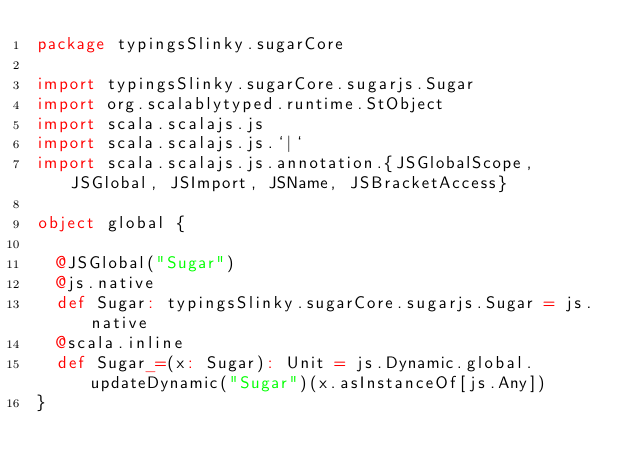<code> <loc_0><loc_0><loc_500><loc_500><_Scala_>package typingsSlinky.sugarCore

import typingsSlinky.sugarCore.sugarjs.Sugar
import org.scalablytyped.runtime.StObject
import scala.scalajs.js
import scala.scalajs.js.`|`
import scala.scalajs.js.annotation.{JSGlobalScope, JSGlobal, JSImport, JSName, JSBracketAccess}

object global {
  
  @JSGlobal("Sugar")
  @js.native
  def Sugar: typingsSlinky.sugarCore.sugarjs.Sugar = js.native
  @scala.inline
  def Sugar_=(x: Sugar): Unit = js.Dynamic.global.updateDynamic("Sugar")(x.asInstanceOf[js.Any])
}
</code> 